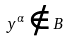Convert formula to latex. <formula><loc_0><loc_0><loc_500><loc_500>y ^ { \alpha } \notin B</formula> 